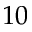<formula> <loc_0><loc_0><loc_500><loc_500>1 0</formula> 